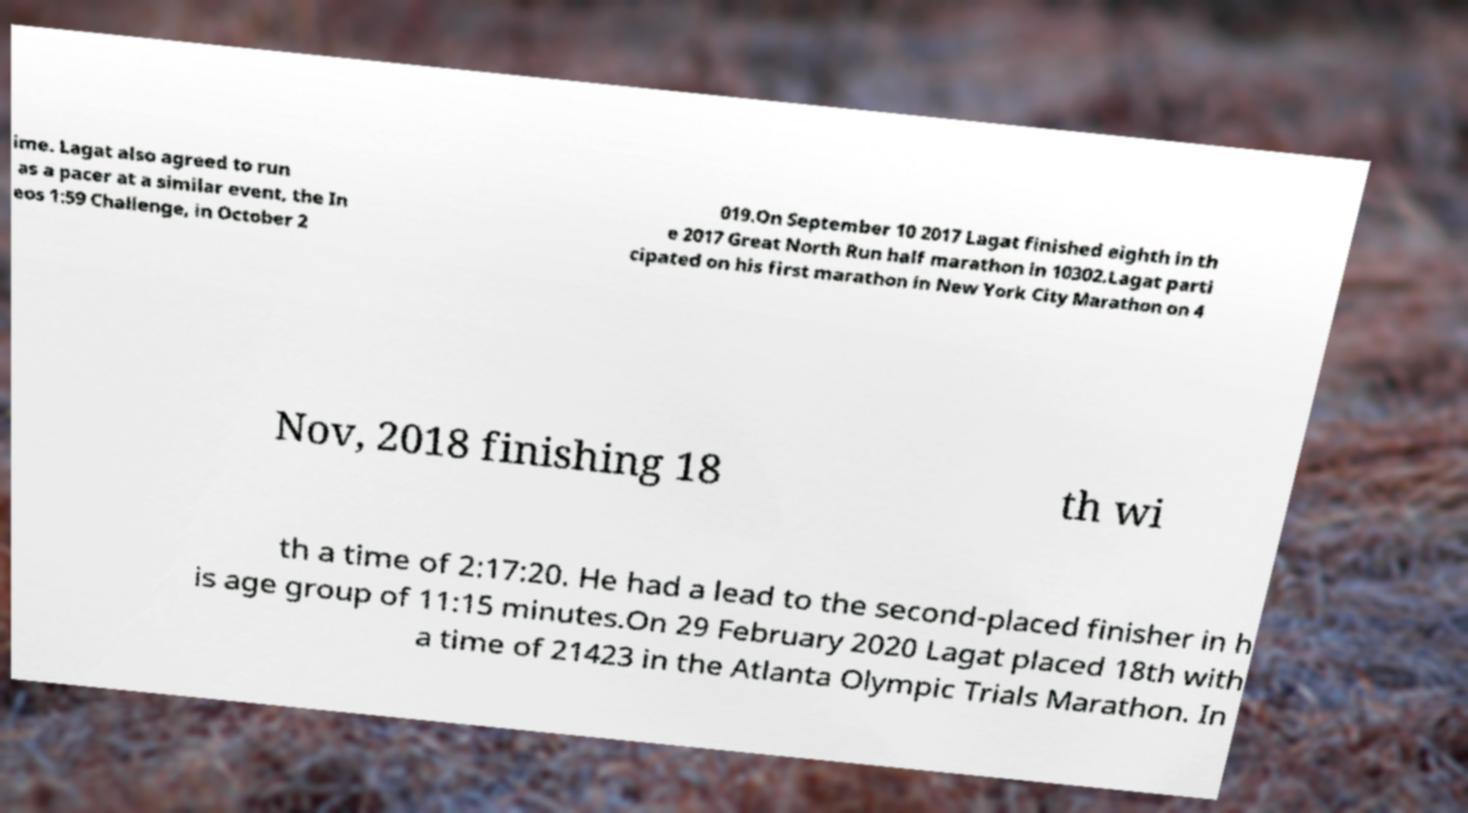Can you read and provide the text displayed in the image?This photo seems to have some interesting text. Can you extract and type it out for me? ime. Lagat also agreed to run as a pacer at a similar event, the In eos 1:59 Challenge, in October 2 019.On September 10 2017 Lagat finished eighth in th e 2017 Great North Run half marathon in 10302.Lagat parti cipated on his first marathon in New York City Marathon on 4 Nov, 2018 finishing 18 th wi th a time of 2:17:20. He had a lead to the second-placed finisher in h is age group of 11:15 minutes.On 29 February 2020 Lagat placed 18th with a time of 21423 in the Atlanta Olympic Trials Marathon. In 